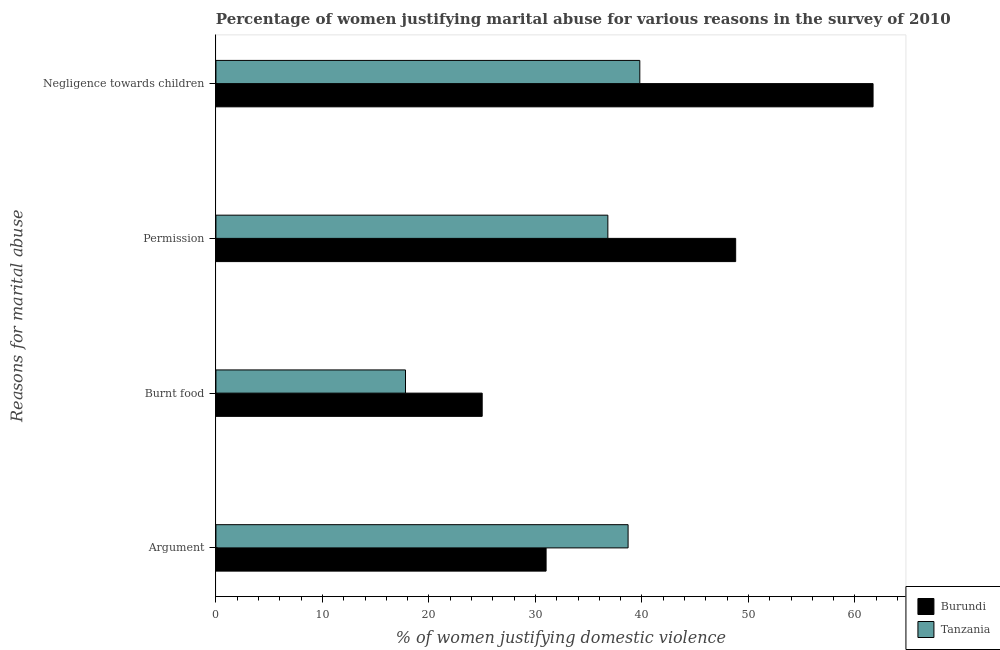Are the number of bars on each tick of the Y-axis equal?
Your answer should be compact. Yes. How many bars are there on the 2nd tick from the top?
Provide a short and direct response. 2. What is the label of the 1st group of bars from the top?
Your answer should be compact. Negligence towards children. What is the percentage of women justifying abuse for going without permission in Tanzania?
Your answer should be compact. 36.8. Across all countries, what is the maximum percentage of women justifying abuse for going without permission?
Make the answer very short. 48.8. Across all countries, what is the minimum percentage of women justifying abuse for burning food?
Keep it short and to the point. 17.8. In which country was the percentage of women justifying abuse in the case of an argument maximum?
Your response must be concise. Tanzania. In which country was the percentage of women justifying abuse for going without permission minimum?
Provide a succinct answer. Tanzania. What is the total percentage of women justifying abuse for going without permission in the graph?
Your response must be concise. 85.6. What is the difference between the percentage of women justifying abuse for showing negligence towards children in Burundi and that in Tanzania?
Offer a terse response. 21.9. What is the difference between the percentage of women justifying abuse in the case of an argument in Tanzania and the percentage of women justifying abuse for burning food in Burundi?
Offer a terse response. 13.7. What is the average percentage of women justifying abuse for burning food per country?
Your answer should be very brief. 21.4. What is the difference between the percentage of women justifying abuse in the case of an argument and percentage of women justifying abuse for showing negligence towards children in Tanzania?
Ensure brevity in your answer.  -1.1. What is the ratio of the percentage of women justifying abuse in the case of an argument in Burundi to that in Tanzania?
Give a very brief answer. 0.8. Is the percentage of women justifying abuse in the case of an argument in Burundi less than that in Tanzania?
Offer a very short reply. Yes. Is the difference between the percentage of women justifying abuse in the case of an argument in Burundi and Tanzania greater than the difference between the percentage of women justifying abuse for burning food in Burundi and Tanzania?
Provide a short and direct response. No. What is the difference between the highest and the lowest percentage of women justifying abuse for going without permission?
Your response must be concise. 12. In how many countries, is the percentage of women justifying abuse in the case of an argument greater than the average percentage of women justifying abuse in the case of an argument taken over all countries?
Provide a succinct answer. 1. Is the sum of the percentage of women justifying abuse for going without permission in Burundi and Tanzania greater than the maximum percentage of women justifying abuse in the case of an argument across all countries?
Ensure brevity in your answer.  Yes. Is it the case that in every country, the sum of the percentage of women justifying abuse for showing negligence towards children and percentage of women justifying abuse in the case of an argument is greater than the sum of percentage of women justifying abuse for burning food and percentage of women justifying abuse for going without permission?
Your answer should be compact. Yes. What does the 1st bar from the top in Negligence towards children represents?
Keep it short and to the point. Tanzania. What does the 2nd bar from the bottom in Negligence towards children represents?
Your response must be concise. Tanzania. Are all the bars in the graph horizontal?
Your response must be concise. Yes. How many countries are there in the graph?
Provide a succinct answer. 2. Does the graph contain grids?
Give a very brief answer. No. Where does the legend appear in the graph?
Ensure brevity in your answer.  Bottom right. How are the legend labels stacked?
Give a very brief answer. Vertical. What is the title of the graph?
Your answer should be compact. Percentage of women justifying marital abuse for various reasons in the survey of 2010. Does "Moldova" appear as one of the legend labels in the graph?
Make the answer very short. No. What is the label or title of the X-axis?
Keep it short and to the point. % of women justifying domestic violence. What is the label or title of the Y-axis?
Your response must be concise. Reasons for marital abuse. What is the % of women justifying domestic violence of Burundi in Argument?
Offer a terse response. 31. What is the % of women justifying domestic violence of Tanzania in Argument?
Make the answer very short. 38.7. What is the % of women justifying domestic violence in Tanzania in Burnt food?
Your answer should be very brief. 17.8. What is the % of women justifying domestic violence of Burundi in Permission?
Keep it short and to the point. 48.8. What is the % of women justifying domestic violence of Tanzania in Permission?
Keep it short and to the point. 36.8. What is the % of women justifying domestic violence in Burundi in Negligence towards children?
Your answer should be compact. 61.7. What is the % of women justifying domestic violence in Tanzania in Negligence towards children?
Provide a short and direct response. 39.8. Across all Reasons for marital abuse, what is the maximum % of women justifying domestic violence of Burundi?
Keep it short and to the point. 61.7. Across all Reasons for marital abuse, what is the maximum % of women justifying domestic violence of Tanzania?
Provide a short and direct response. 39.8. Across all Reasons for marital abuse, what is the minimum % of women justifying domestic violence in Tanzania?
Your response must be concise. 17.8. What is the total % of women justifying domestic violence of Burundi in the graph?
Provide a succinct answer. 166.5. What is the total % of women justifying domestic violence of Tanzania in the graph?
Provide a short and direct response. 133.1. What is the difference between the % of women justifying domestic violence of Tanzania in Argument and that in Burnt food?
Provide a succinct answer. 20.9. What is the difference between the % of women justifying domestic violence in Burundi in Argument and that in Permission?
Your response must be concise. -17.8. What is the difference between the % of women justifying domestic violence of Burundi in Argument and that in Negligence towards children?
Your response must be concise. -30.7. What is the difference between the % of women justifying domestic violence of Tanzania in Argument and that in Negligence towards children?
Provide a short and direct response. -1.1. What is the difference between the % of women justifying domestic violence in Burundi in Burnt food and that in Permission?
Provide a short and direct response. -23.8. What is the difference between the % of women justifying domestic violence in Burundi in Burnt food and that in Negligence towards children?
Keep it short and to the point. -36.7. What is the difference between the % of women justifying domestic violence of Tanzania in Burnt food and that in Negligence towards children?
Your answer should be compact. -22. What is the difference between the % of women justifying domestic violence in Burundi in Permission and that in Negligence towards children?
Give a very brief answer. -12.9. What is the difference between the % of women justifying domestic violence in Burundi in Argument and the % of women justifying domestic violence in Tanzania in Burnt food?
Your answer should be very brief. 13.2. What is the difference between the % of women justifying domestic violence of Burundi in Argument and the % of women justifying domestic violence of Tanzania in Negligence towards children?
Ensure brevity in your answer.  -8.8. What is the difference between the % of women justifying domestic violence in Burundi in Burnt food and the % of women justifying domestic violence in Tanzania in Permission?
Give a very brief answer. -11.8. What is the difference between the % of women justifying domestic violence in Burundi in Burnt food and the % of women justifying domestic violence in Tanzania in Negligence towards children?
Your response must be concise. -14.8. What is the average % of women justifying domestic violence in Burundi per Reasons for marital abuse?
Provide a short and direct response. 41.62. What is the average % of women justifying domestic violence of Tanzania per Reasons for marital abuse?
Offer a terse response. 33.27. What is the difference between the % of women justifying domestic violence in Burundi and % of women justifying domestic violence in Tanzania in Argument?
Ensure brevity in your answer.  -7.7. What is the difference between the % of women justifying domestic violence in Burundi and % of women justifying domestic violence in Tanzania in Negligence towards children?
Keep it short and to the point. 21.9. What is the ratio of the % of women justifying domestic violence in Burundi in Argument to that in Burnt food?
Provide a succinct answer. 1.24. What is the ratio of the % of women justifying domestic violence in Tanzania in Argument to that in Burnt food?
Give a very brief answer. 2.17. What is the ratio of the % of women justifying domestic violence in Burundi in Argument to that in Permission?
Provide a short and direct response. 0.64. What is the ratio of the % of women justifying domestic violence in Tanzania in Argument to that in Permission?
Make the answer very short. 1.05. What is the ratio of the % of women justifying domestic violence in Burundi in Argument to that in Negligence towards children?
Provide a short and direct response. 0.5. What is the ratio of the % of women justifying domestic violence in Tanzania in Argument to that in Negligence towards children?
Give a very brief answer. 0.97. What is the ratio of the % of women justifying domestic violence in Burundi in Burnt food to that in Permission?
Your response must be concise. 0.51. What is the ratio of the % of women justifying domestic violence in Tanzania in Burnt food to that in Permission?
Offer a very short reply. 0.48. What is the ratio of the % of women justifying domestic violence of Burundi in Burnt food to that in Negligence towards children?
Your answer should be compact. 0.41. What is the ratio of the % of women justifying domestic violence in Tanzania in Burnt food to that in Negligence towards children?
Provide a succinct answer. 0.45. What is the ratio of the % of women justifying domestic violence of Burundi in Permission to that in Negligence towards children?
Provide a succinct answer. 0.79. What is the ratio of the % of women justifying domestic violence in Tanzania in Permission to that in Negligence towards children?
Provide a succinct answer. 0.92. What is the difference between the highest and the second highest % of women justifying domestic violence of Burundi?
Your answer should be compact. 12.9. What is the difference between the highest and the second highest % of women justifying domestic violence of Tanzania?
Offer a very short reply. 1.1. What is the difference between the highest and the lowest % of women justifying domestic violence in Burundi?
Your answer should be compact. 36.7. What is the difference between the highest and the lowest % of women justifying domestic violence of Tanzania?
Give a very brief answer. 22. 